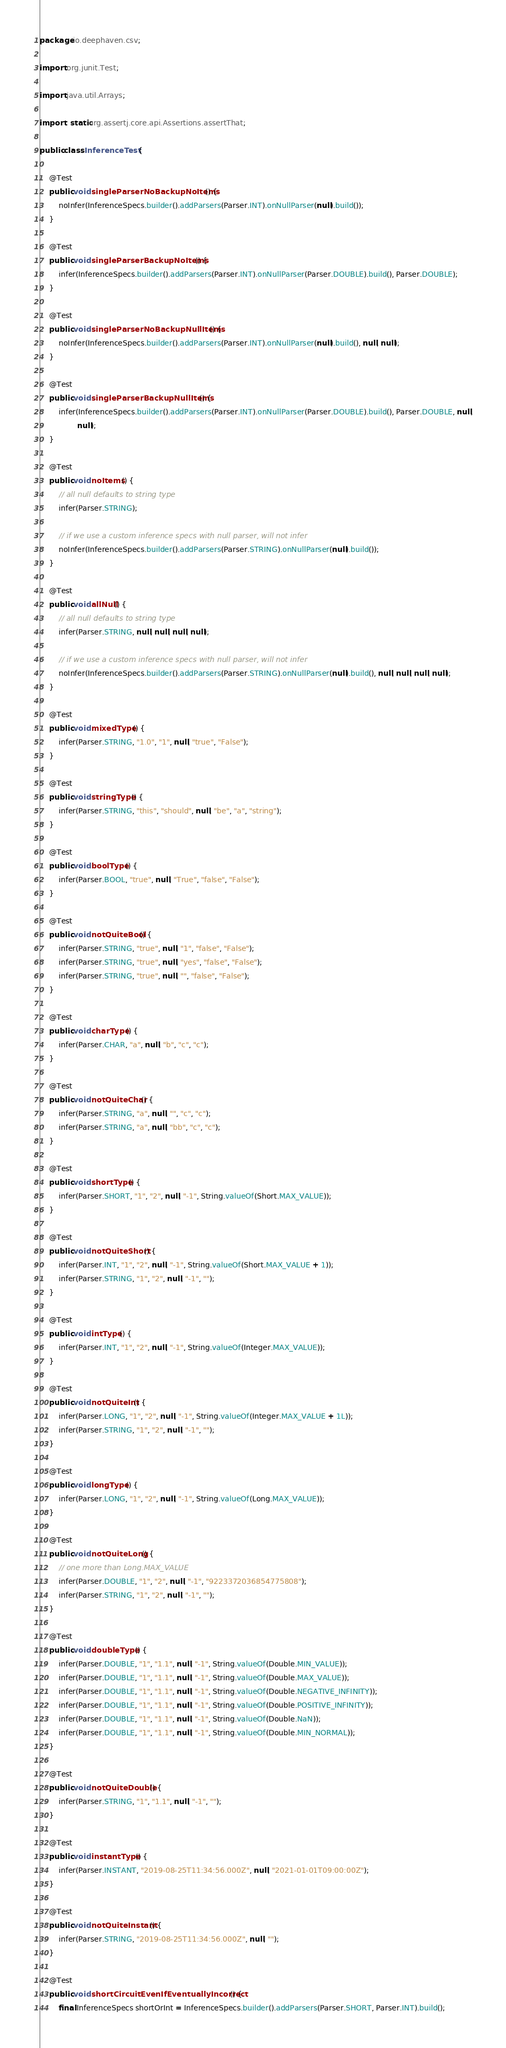Convert code to text. <code><loc_0><loc_0><loc_500><loc_500><_Java_>package io.deephaven.csv;

import org.junit.Test;

import java.util.Arrays;

import static org.assertj.core.api.Assertions.assertThat;

public class InferenceTest {

    @Test
    public void singleParserNoBackupNoItems() {
        noInfer(InferenceSpecs.builder().addParsers(Parser.INT).onNullParser(null).build());
    }

    @Test
    public void singleParserBackupNoItems() {
        infer(InferenceSpecs.builder().addParsers(Parser.INT).onNullParser(Parser.DOUBLE).build(), Parser.DOUBLE);
    }

    @Test
    public void singleParserNoBackupNullItems() {
        noInfer(InferenceSpecs.builder().addParsers(Parser.INT).onNullParser(null).build(), null, null);
    }

    @Test
    public void singleParserBackupNullItems() {
        infer(InferenceSpecs.builder().addParsers(Parser.INT).onNullParser(Parser.DOUBLE).build(), Parser.DOUBLE, null,
                null);
    }

    @Test
    public void noItems() {
        // all null defaults to string type
        infer(Parser.STRING);

        // if we use a custom inference specs with null parser, will not infer
        noInfer(InferenceSpecs.builder().addParsers(Parser.STRING).onNullParser(null).build());
    }

    @Test
    public void allNull() {
        // all null defaults to string type
        infer(Parser.STRING, null, null, null, null);

        // if we use a custom inference specs with null parser, will not infer
        noInfer(InferenceSpecs.builder().addParsers(Parser.STRING).onNullParser(null).build(), null, null, null, null);
    }

    @Test
    public void mixedType() {
        infer(Parser.STRING, "1.0", "1", null, "true", "False");
    }

    @Test
    public void stringType() {
        infer(Parser.STRING, "this", "should", null, "be", "a", "string");
    }

    @Test
    public void boolType() {
        infer(Parser.BOOL, "true", null, "True", "false", "False");
    }

    @Test
    public void notQuiteBool() {
        infer(Parser.STRING, "true", null, "1", "false", "False");
        infer(Parser.STRING, "true", null, "yes", "false", "False");
        infer(Parser.STRING, "true", null, "", "false", "False");
    }

    @Test
    public void charType() {
        infer(Parser.CHAR, "a", null, "b", "c", "c");
    }

    @Test
    public void notQuiteChar() {
        infer(Parser.STRING, "a", null, "", "c", "c");
        infer(Parser.STRING, "a", null, "bb", "c", "c");
    }

    @Test
    public void shortType() {
        infer(Parser.SHORT, "1", "2", null, "-1", String.valueOf(Short.MAX_VALUE));
    }

    @Test
    public void notQuiteShort() {
        infer(Parser.INT, "1", "2", null, "-1", String.valueOf(Short.MAX_VALUE + 1));
        infer(Parser.STRING, "1", "2", null, "-1", "");
    }

    @Test
    public void intType() {
        infer(Parser.INT, "1", "2", null, "-1", String.valueOf(Integer.MAX_VALUE));
    }

    @Test
    public void notQuiteInt() {
        infer(Parser.LONG, "1", "2", null, "-1", String.valueOf(Integer.MAX_VALUE + 1L));
        infer(Parser.STRING, "1", "2", null, "-1", "");
    }

    @Test
    public void longType() {
        infer(Parser.LONG, "1", "2", null, "-1", String.valueOf(Long.MAX_VALUE));
    }

    @Test
    public void notQuiteLong() {
        // one more than Long.MAX_VALUE
        infer(Parser.DOUBLE, "1", "2", null, "-1", "9223372036854775808");
        infer(Parser.STRING, "1", "2", null, "-1", "");
    }

    @Test
    public void doubleType() {
        infer(Parser.DOUBLE, "1", "1.1", null, "-1", String.valueOf(Double.MIN_VALUE));
        infer(Parser.DOUBLE, "1", "1.1", null, "-1", String.valueOf(Double.MAX_VALUE));
        infer(Parser.DOUBLE, "1", "1.1", null, "-1", String.valueOf(Double.NEGATIVE_INFINITY));
        infer(Parser.DOUBLE, "1", "1.1", null, "-1", String.valueOf(Double.POSITIVE_INFINITY));
        infer(Parser.DOUBLE, "1", "1.1", null, "-1", String.valueOf(Double.NaN));
        infer(Parser.DOUBLE, "1", "1.1", null, "-1", String.valueOf(Double.MIN_NORMAL));
    }

    @Test
    public void notQuiteDouble() {
        infer(Parser.STRING, "1", "1.1", null, "-1", "");
    }

    @Test
    public void instantType() {
        infer(Parser.INSTANT, "2019-08-25T11:34:56.000Z", null, "2021-01-01T09:00:00Z");
    }

    @Test
    public void notQuiteInstant() {
        infer(Parser.STRING, "2019-08-25T11:34:56.000Z", null, "");
    }

    @Test
    public void shortCircuitEvenIfEventuallyIncorrect() {
        final InferenceSpecs shortOrInt = InferenceSpecs.builder().addParsers(Parser.SHORT, Parser.INT).build();</code> 